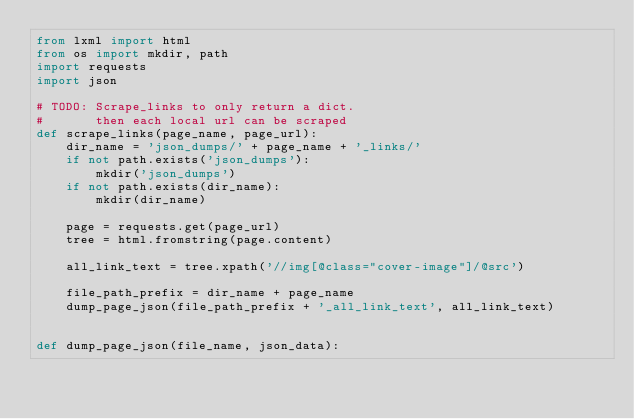Convert code to text. <code><loc_0><loc_0><loc_500><loc_500><_Python_>from lxml import html
from os import mkdir, path
import requests
import json

# TODO: Scrape_links to only return a dict.
#       then each local url can be scraped
def scrape_links(page_name, page_url):
    dir_name = 'json_dumps/' + page_name + '_links/'
    if not path.exists('json_dumps'):
        mkdir('json_dumps')
    if not path.exists(dir_name):
        mkdir(dir_name)

    page = requests.get(page_url)
    tree = html.fromstring(page.content)

    all_link_text = tree.xpath('//img[@class="cover-image"]/@src')

    file_path_prefix = dir_name + page_name
    dump_page_json(file_path_prefix + '_all_link_text', all_link_text)


def dump_page_json(file_name, json_data):</code> 